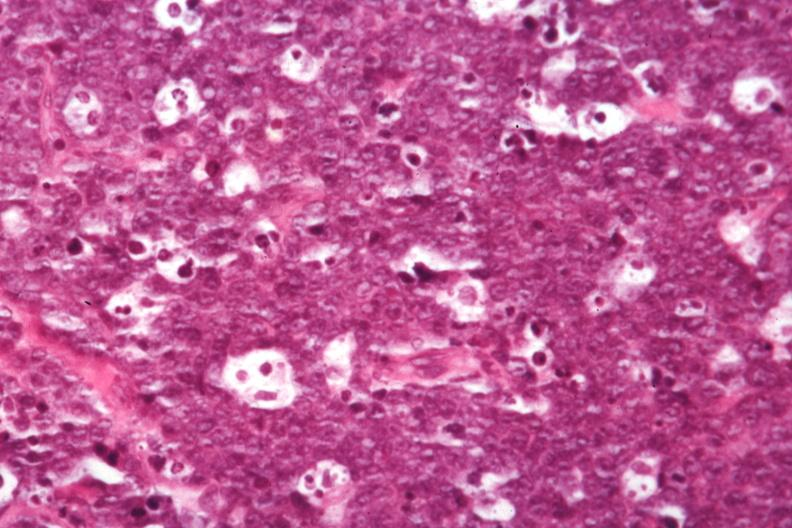does this image show good starry sky detail in large lymphocytes not so good?
Answer the question using a single word or phrase. Yes 